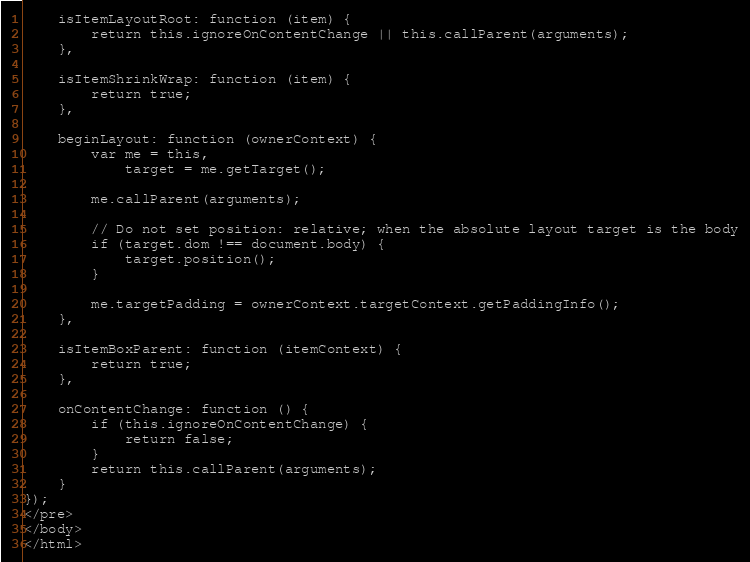Convert code to text. <code><loc_0><loc_0><loc_500><loc_500><_HTML_>    isItemLayoutRoot: function (item) {
        return this.ignoreOnContentChange || this.callParent(arguments);
    },

    isItemShrinkWrap: function (item) {
        return true;
    },

    beginLayout: function (ownerContext) {
        var me = this,
            target = me.getTarget();

        me.callParent(arguments);

        // Do not set position: relative; when the absolute layout target is the body
        if (target.dom !== document.body) {
            target.position();
        }

        me.targetPadding = ownerContext.targetContext.getPaddingInfo();
    },

    isItemBoxParent: function (itemContext) {
        return true;
    },

    onContentChange: function () {
        if (this.ignoreOnContentChange) {
            return false;
        }
        return this.callParent(arguments);
    }
});
</pre>
</body>
</html>
</code> 